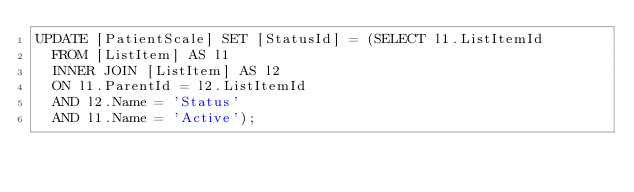Convert code to text. <code><loc_0><loc_0><loc_500><loc_500><_SQL_>UPDATE [PatientScale] SET [StatusId] = (SELECT l1.ListItemId
  FROM [ListItem] AS l1
  INNER JOIN [ListItem] AS l2
  ON l1.ParentId = l2.ListItemId 
  AND l2.Name = 'Status'
  AND l1.Name = 'Active');

</code> 